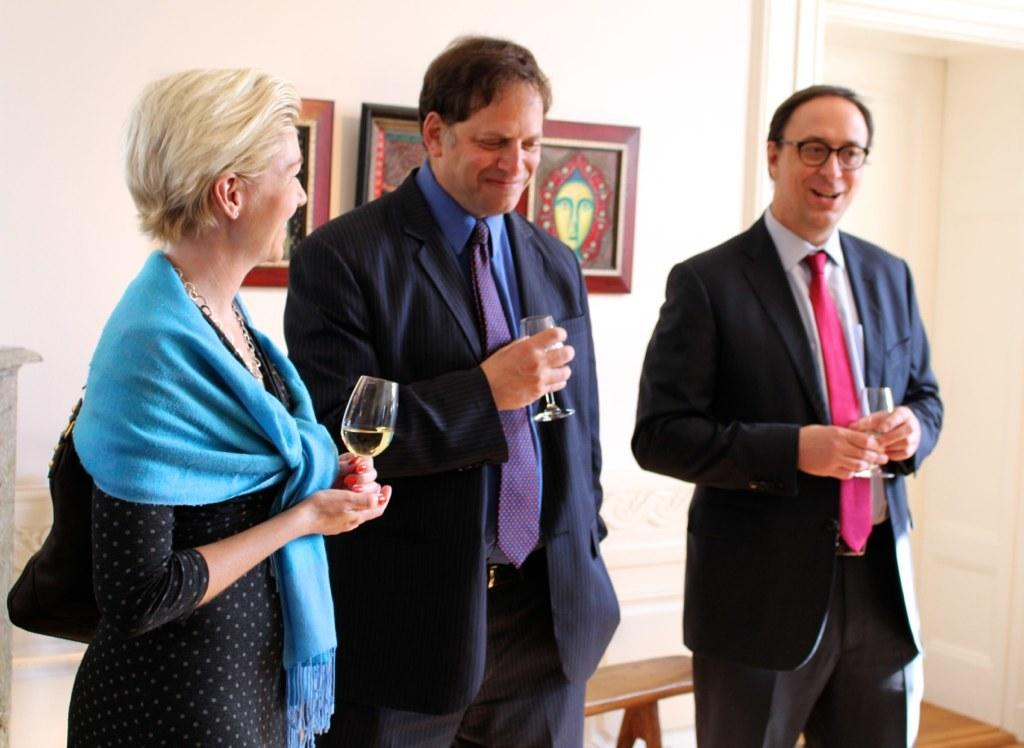What are the people in the image holding? The people in the image are holding glasses. What can be seen on the wall in the image? There are frames on the wall in the image. What type of material is used for some of the objects in the image? There are wooden objects in the image. What is the main architectural feature visible in the image? There is a wall in the image. Can you see any children playing with feathers in the image? There are no children or feathers present in the image. How does the breath of the people holding glasses affect the image? The breath of the people holding glasses is not visible in the image, so it cannot be determined how it affects the image. 